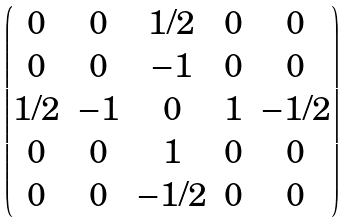<formula> <loc_0><loc_0><loc_500><loc_500>\begin{pmatrix} 0 & 0 & 1 / 2 & 0 & 0 \\ 0 & 0 & - 1 & 0 & 0 \\ 1 / 2 & - 1 & 0 & 1 & - 1 / 2 \\ 0 & 0 & 1 & 0 & 0 \\ 0 & 0 & - 1 / 2 & 0 & 0 \end{pmatrix}</formula> 